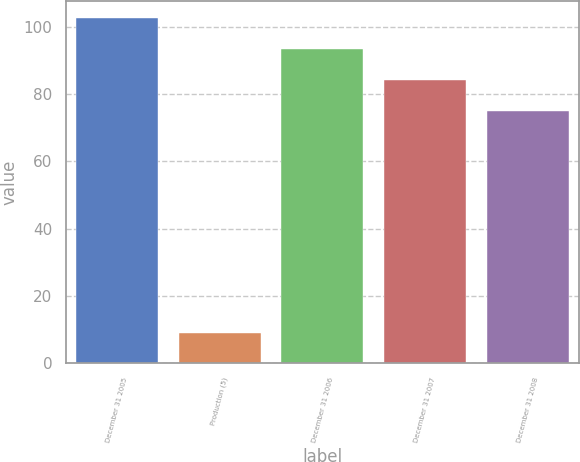Convert chart. <chart><loc_0><loc_0><loc_500><loc_500><bar_chart><fcel>December 31 2005<fcel>Production (5)<fcel>December 31 2006<fcel>December 31 2007<fcel>December 31 2008<nl><fcel>102.6<fcel>9<fcel>93.4<fcel>84.2<fcel>75<nl></chart> 